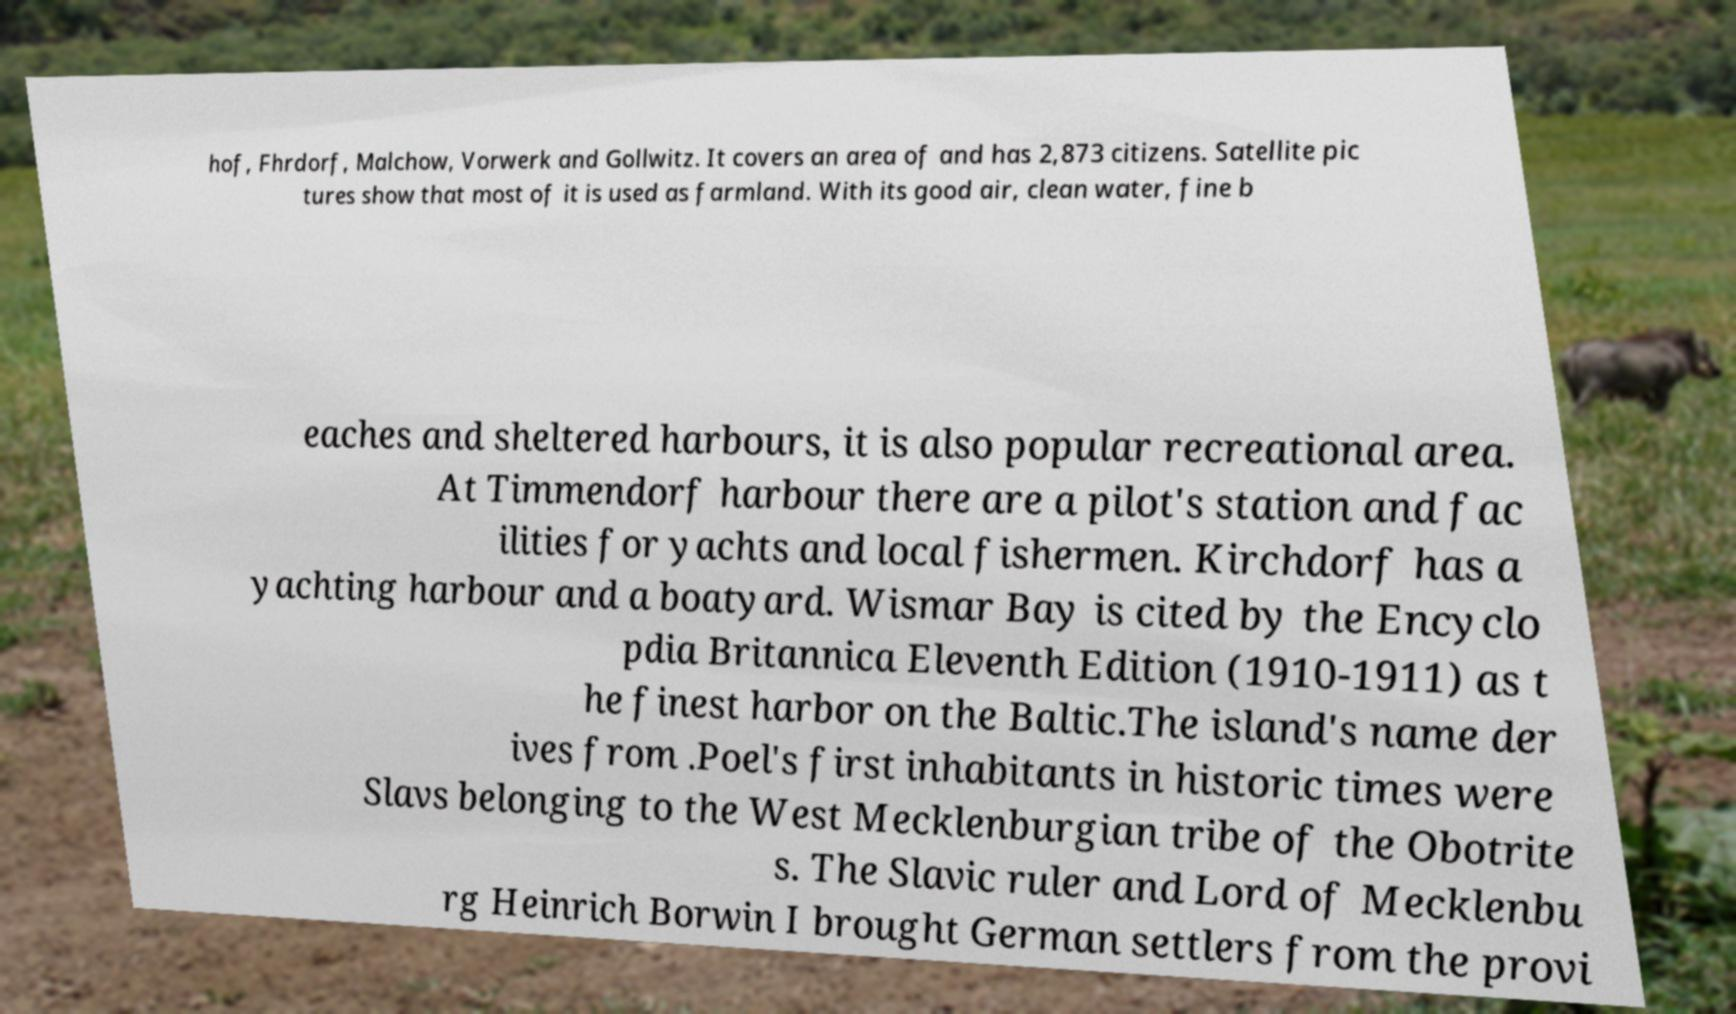Could you extract and type out the text from this image? hof, Fhrdorf, Malchow, Vorwerk and Gollwitz. It covers an area of and has 2,873 citizens. Satellite pic tures show that most of it is used as farmland. With its good air, clean water, fine b eaches and sheltered harbours, it is also popular recreational area. At Timmendorf harbour there are a pilot's station and fac ilities for yachts and local fishermen. Kirchdorf has a yachting harbour and a boatyard. Wismar Bay is cited by the Encyclo pdia Britannica Eleventh Edition (1910-1911) as t he finest harbor on the Baltic.The island's name der ives from .Poel's first inhabitants in historic times were Slavs belonging to the West Mecklenburgian tribe of the Obotrite s. The Slavic ruler and Lord of Mecklenbu rg Heinrich Borwin I brought German settlers from the provi 